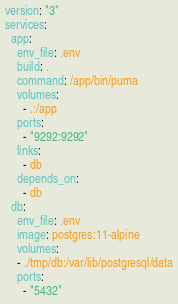Convert code to text. <code><loc_0><loc_0><loc_500><loc_500><_YAML_>version: "3"
services:
  app:
    env_file: .env
    build: .
    command: /app/bin/puma
    volumes:
      - .:/app
    ports:
      - "9292:9292"
    links:
      - db
    depends_on:
      - db
  db:
    env_file: .env
    image: postgres:11-alpine
    volumes:
    - ./tmp/db:/var/lib/postgresql/data
    ports:
      - "5432"
</code> 